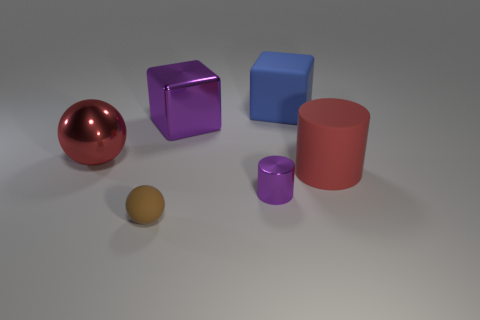Is there a tiny cylinder to the left of the big rubber thing that is behind the red object on the right side of the brown matte thing? Yes, there is a small purple cylinder situated to the left of the larger red cylinder, which is positioned behind the reflective red sphere to the right of the large brown sphere. 